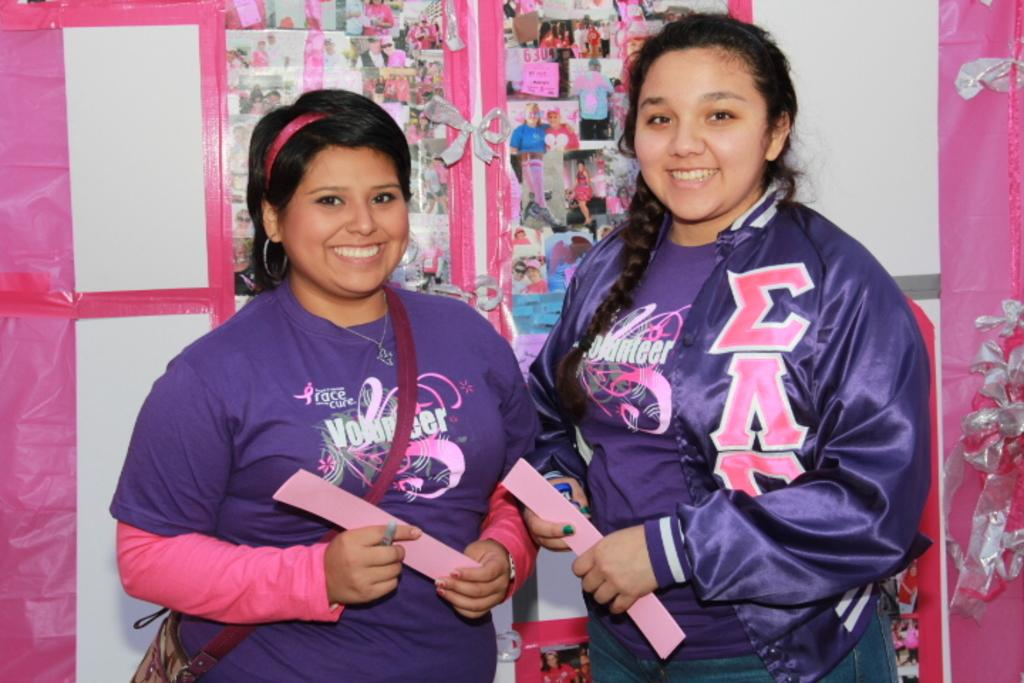<image>
Offer a succinct explanation of the picture presented. Two young girls wearing matching breast cancer awareness shirts are standing in front of a hand made collage of photo's of women. 